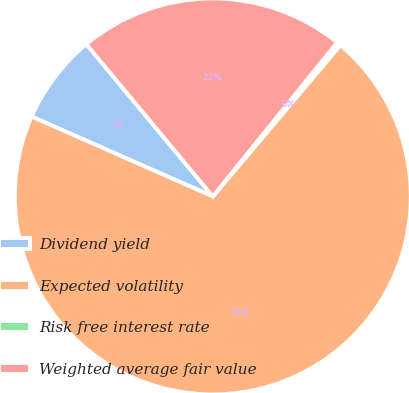Convert chart. <chart><loc_0><loc_0><loc_500><loc_500><pie_chart><fcel>Dividend yield<fcel>Expected volatility<fcel>Risk free interest rate<fcel>Weighted average fair value<nl><fcel>7.36%<fcel>70.46%<fcel>0.34%<fcel>21.84%<nl></chart> 